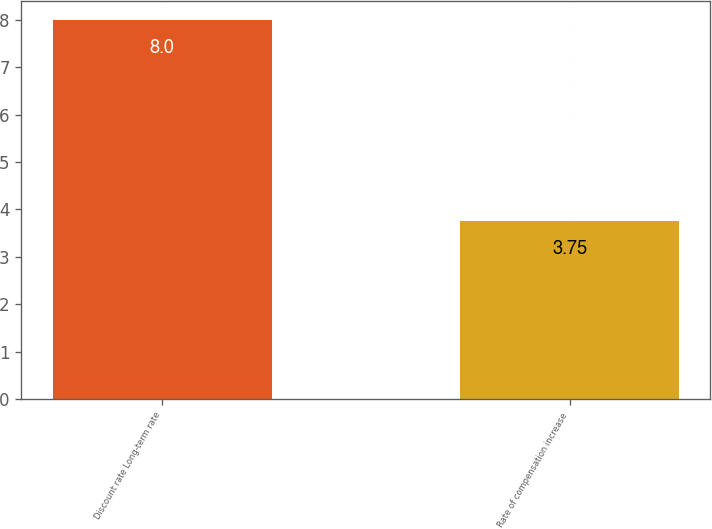Convert chart to OTSL. <chart><loc_0><loc_0><loc_500><loc_500><bar_chart><fcel>Discount rate Long-term rate<fcel>Rate of compensation increase<nl><fcel>8<fcel>3.75<nl></chart> 